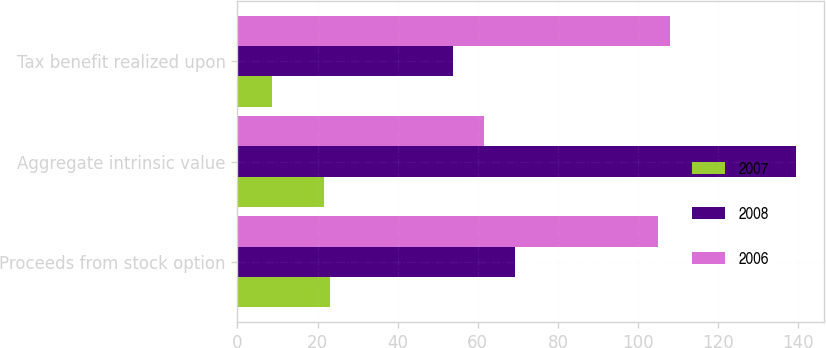Convert chart. <chart><loc_0><loc_0><loc_500><loc_500><stacked_bar_chart><ecel><fcel>Proceeds from stock option<fcel>Aggregate intrinsic value<fcel>Tax benefit realized upon<nl><fcel>2007<fcel>23.2<fcel>21.6<fcel>8.5<nl><fcel>2008<fcel>69.3<fcel>139.4<fcel>53.9<nl><fcel>2006<fcel>105<fcel>61.6<fcel>108<nl></chart> 